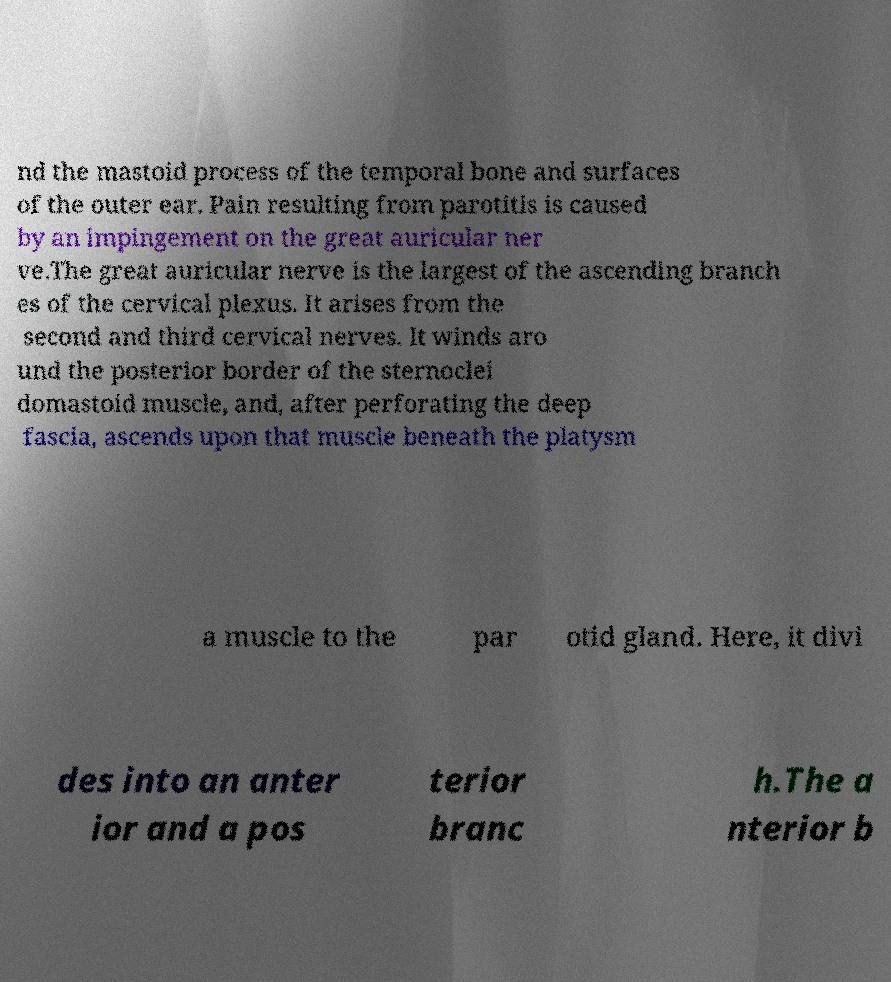Can you accurately transcribe the text from the provided image for me? nd the mastoid process of the temporal bone and surfaces of the outer ear. Pain resulting from parotitis is caused by an impingement on the great auricular ner ve.The great auricular nerve is the largest of the ascending branch es of the cervical plexus. It arises from the second and third cervical nerves. It winds aro und the posterior border of the sternoclei domastoid muscle, and, after perforating the deep fascia, ascends upon that muscle beneath the platysm a muscle to the par otid gland. Here, it divi des into an anter ior and a pos terior branc h.The a nterior b 